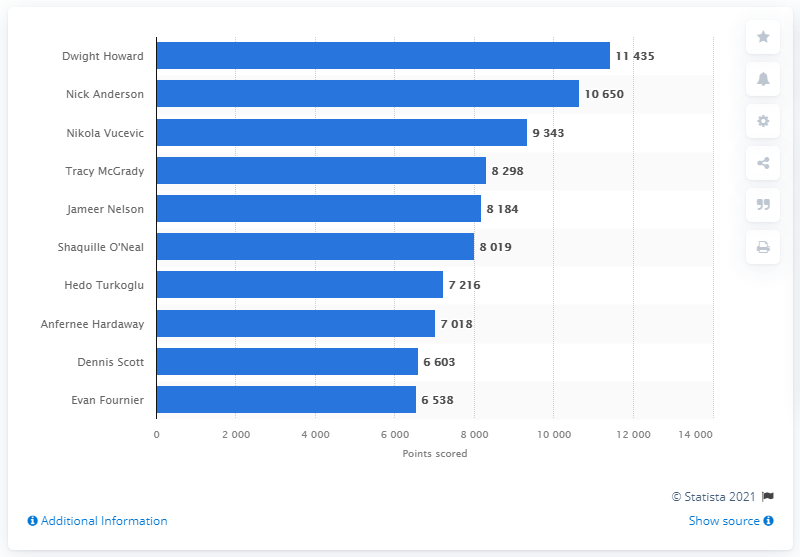Mention a couple of crucial points in this snapshot. Dwight Howard is the career points leader of the Orlando Magic. 